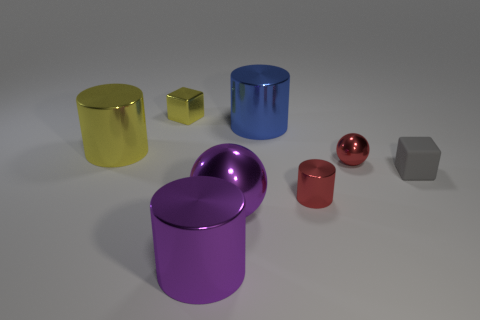Are there more large green metallic blocks than big blue shiny cylinders?
Offer a terse response. No. What number of metal things are both on the left side of the big blue thing and in front of the yellow cylinder?
Your response must be concise. 2. There is a big shiny object to the left of the purple thing on the left side of the metal ball that is in front of the tiny matte thing; what shape is it?
Ensure brevity in your answer.  Cylinder. Are there any other things that are the same shape as the tiny gray object?
Your answer should be compact. Yes. What number of cylinders are either big blue things or tiny yellow metal things?
Keep it short and to the point. 1. There is a tiny metal thing that is in front of the tiny matte block; does it have the same color as the small ball?
Offer a very short reply. Yes. What material is the block that is in front of the big cylinder on the left side of the tiny cube behind the tiny ball?
Your response must be concise. Rubber. Do the yellow cylinder and the gray cube have the same size?
Give a very brief answer. No. Does the metal block have the same color as the big thing that is to the left of the small yellow shiny object?
Provide a succinct answer. Yes. What shape is the blue object that is the same material as the big yellow cylinder?
Give a very brief answer. Cylinder. 